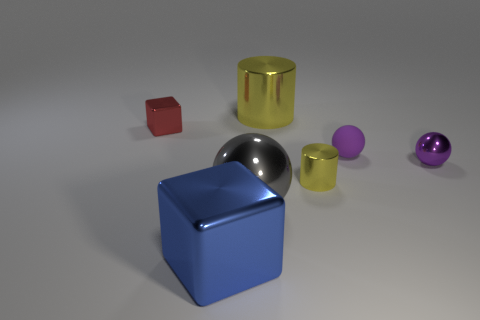Subtract all purple balls. How many balls are left? 1 Add 2 red shiny objects. How many objects exist? 9 Subtract all green blocks. How many purple balls are left? 2 Subtract all gray spheres. How many spheres are left? 2 Subtract all cubes. How many objects are left? 5 Add 1 large shiny cylinders. How many large shiny cylinders exist? 2 Subtract 0 cyan blocks. How many objects are left? 7 Subtract all gray cubes. Subtract all cyan spheres. How many cubes are left? 2 Subtract all large metallic cubes. Subtract all gray shiny things. How many objects are left? 5 Add 7 cylinders. How many cylinders are left? 9 